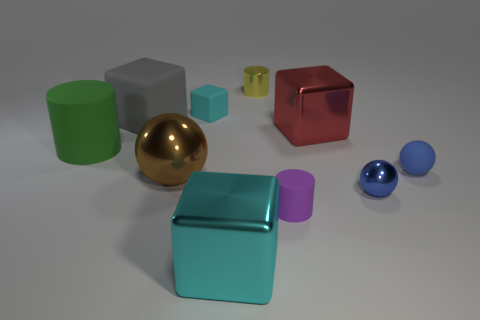How many small red metallic objects are there?
Your answer should be compact. 0. There is another big object that is the same material as the green thing; what is its shape?
Provide a short and direct response. Cube. There is a metal block in front of the large green matte cylinder; is its color the same as the small rubber thing to the left of the yellow cylinder?
Offer a very short reply. Yes. Are there the same number of tiny cylinders left of the small yellow metallic cylinder and tiny purple shiny objects?
Ensure brevity in your answer.  Yes. There is a big green thing; how many cylinders are to the right of it?
Your response must be concise. 2. The matte sphere has what size?
Provide a short and direct response. Small. The other ball that is made of the same material as the big brown sphere is what color?
Offer a very short reply. Blue. How many red shiny objects have the same size as the blue rubber ball?
Give a very brief answer. 0. Do the block on the left side of the large brown metallic ball and the brown sphere have the same material?
Ensure brevity in your answer.  No. Are there fewer tiny blue metal spheres that are right of the tiny cyan matte block than gray blocks?
Ensure brevity in your answer.  No. 